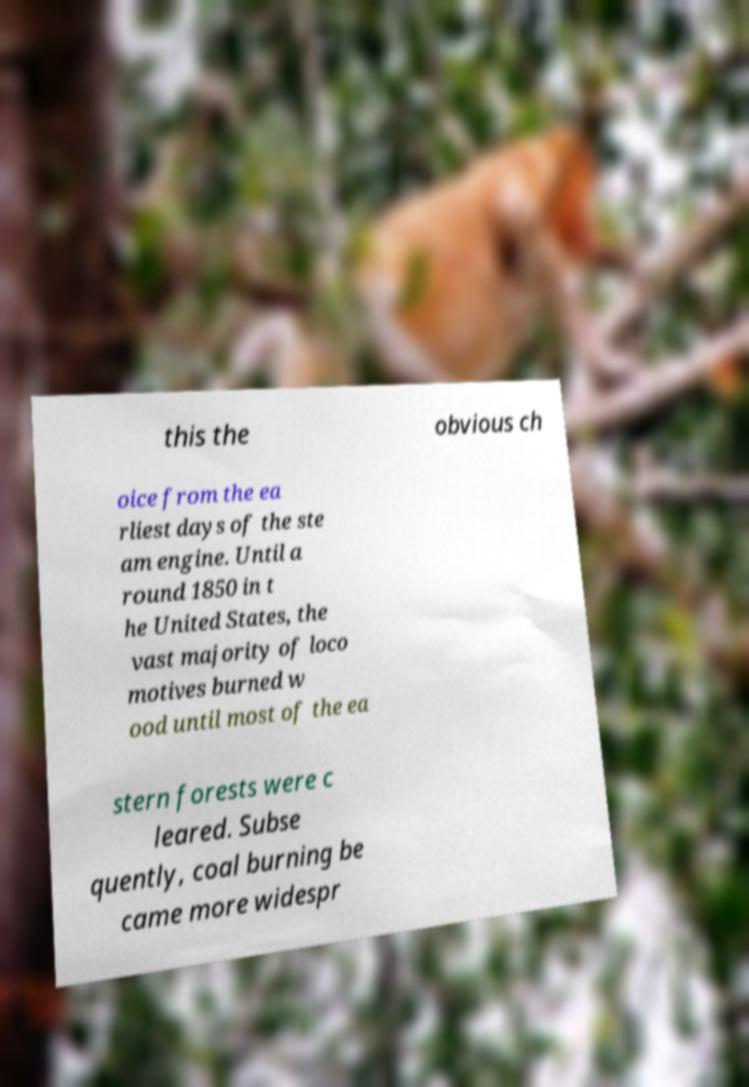For documentation purposes, I need the text within this image transcribed. Could you provide that? this the obvious ch oice from the ea rliest days of the ste am engine. Until a round 1850 in t he United States, the vast majority of loco motives burned w ood until most of the ea stern forests were c leared. Subse quently, coal burning be came more widespr 